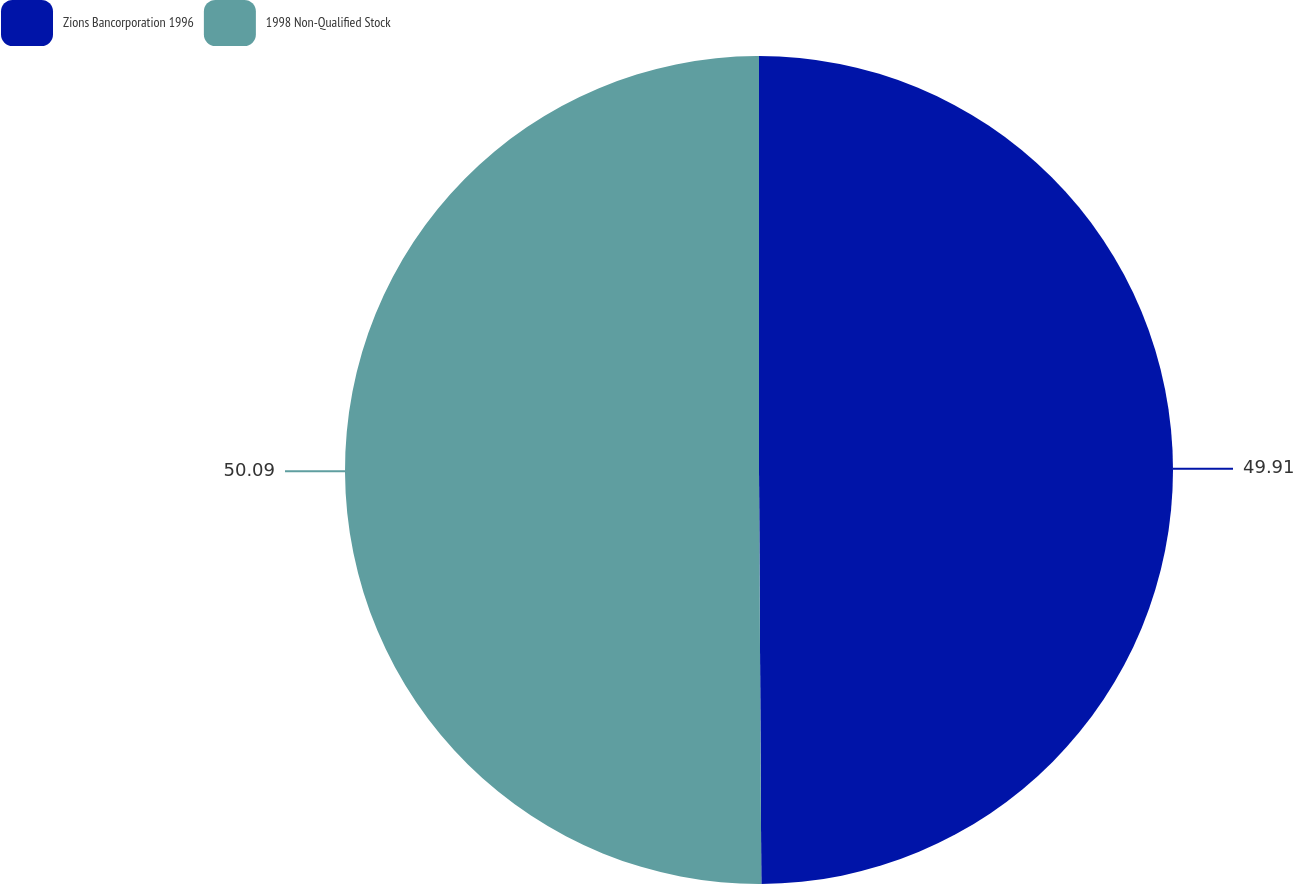Convert chart to OTSL. <chart><loc_0><loc_0><loc_500><loc_500><pie_chart><fcel>Zions Bancorporation 1996<fcel>1998 Non-Qualified Stock<nl><fcel>49.91%<fcel>50.09%<nl></chart> 